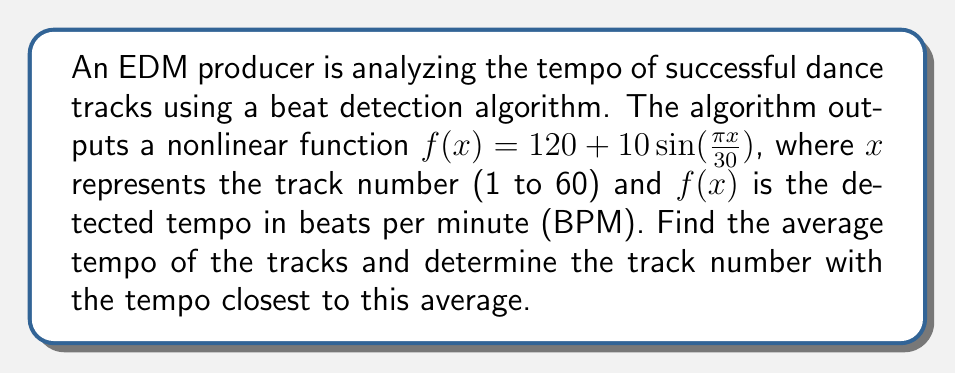Show me your answer to this math problem. 1) To find the average tempo, we need to integrate the function over the range of tracks and divide by the number of tracks:

   Average tempo = $\frac{1}{60} \int_0^{60} f(x) dx$

2) Substituting the function:

   $\frac{1}{60} \int_0^{60} (120 + 10\sin(\frac{\pi x}{30})) dx$

3) Integrate:

   $\frac{1}{60} [120x - \frac{300}{\pi}\cos(\frac{\pi x}{30})]_0^{60}$

4) Evaluate the integral:

   $\frac{1}{60} [(120 \cdot 60 - \frac{300}{\pi}\cos(2\pi)) - (0 - \frac{300}{\pi}\cos(0))]$

   $\frac{1}{60} [7200 - \frac{300}{\pi} + \frac{300}{\pi}] = \frac{7200}{60} = 120$ BPM

5) To find the track with tempo closest to 120 BPM, we need to solve:

   $120 + 10\sin(\frac{\pi x}{30}) = 120$

6) This simplifies to:

   $\sin(\frac{\pi x}{30}) = 0$

7) The solutions are:

   $\frac{\pi x}{30} = 0, \pi, 2\pi, ...$

   $x = 0, 30, 60, ...$

8) Within our range (1 to 60), the closest solutions are $x = 30$ and $x = 60$.

9) Both track 30 and track 60 have a tempo of exactly 120 BPM, which is the closest to the average.
Answer: Track 30 or 60, both with tempo 120 BPM 